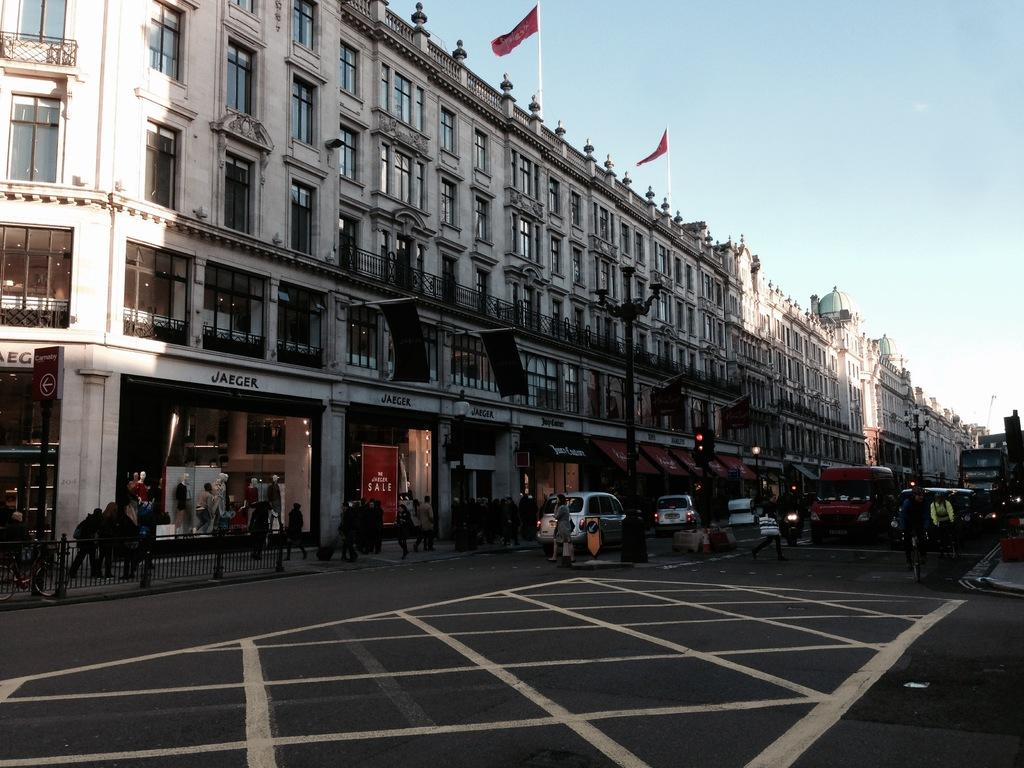What is the main feature of the image? There is a road in the image. What can be seen on the road? There are vehicles and persons on the road. What is visible in the background of the image? There are buildings in the background of the image. Are there any flags visible in the image? Yes, there are two flags on the buildings. What is visible in the sky in the image? The sky is visible in the image. What type of bridge can be seen in the image? There is no bridge present in the image; it features a road with vehicles and persons. How does the rain affect the vehicles on the road in the image? There is no rain present in the image, so its effect on the vehicles cannot be determined. 